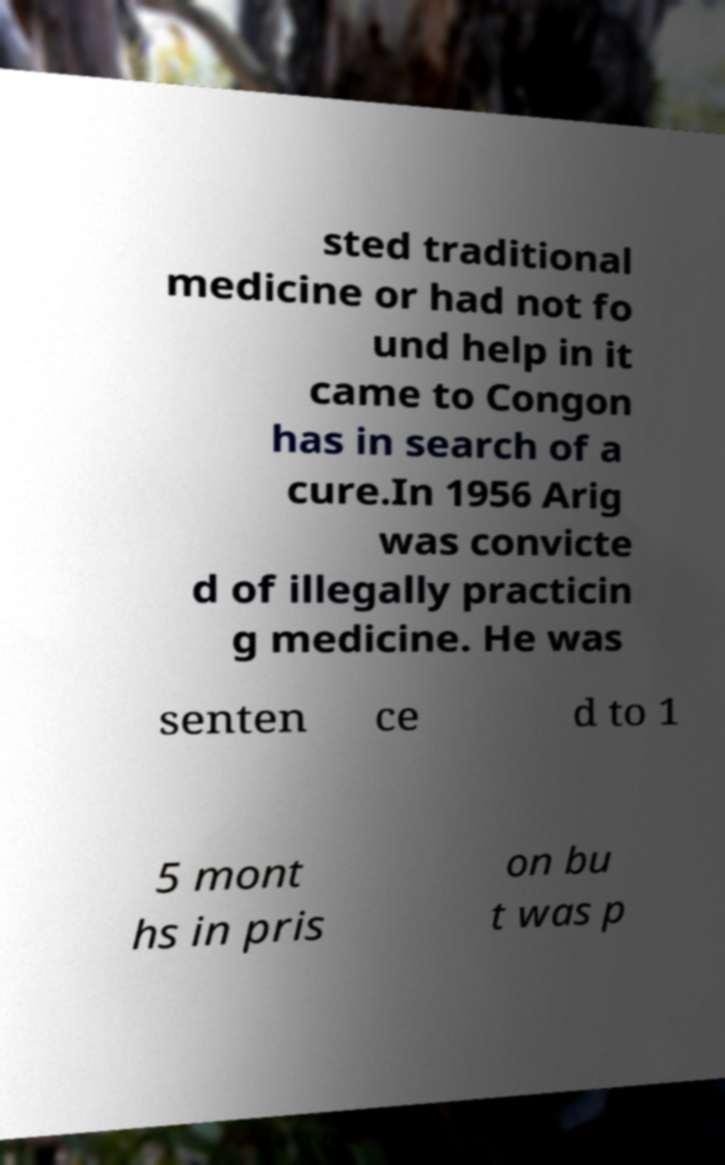Can you read and provide the text displayed in the image?This photo seems to have some interesting text. Can you extract and type it out for me? sted traditional medicine or had not fo und help in it came to Congon has in search of a cure.In 1956 Arig was convicte d of illegally practicin g medicine. He was senten ce d to 1 5 mont hs in pris on bu t was p 